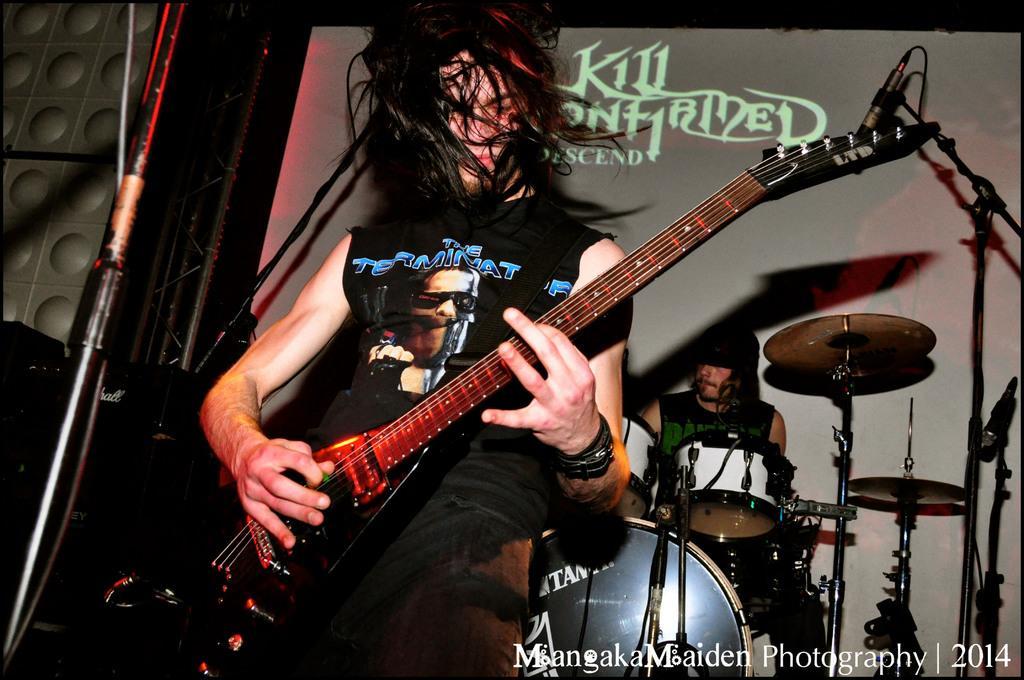How would you summarize this image in a sentence or two? There is a person playing and behind him there is a person playing drums. 